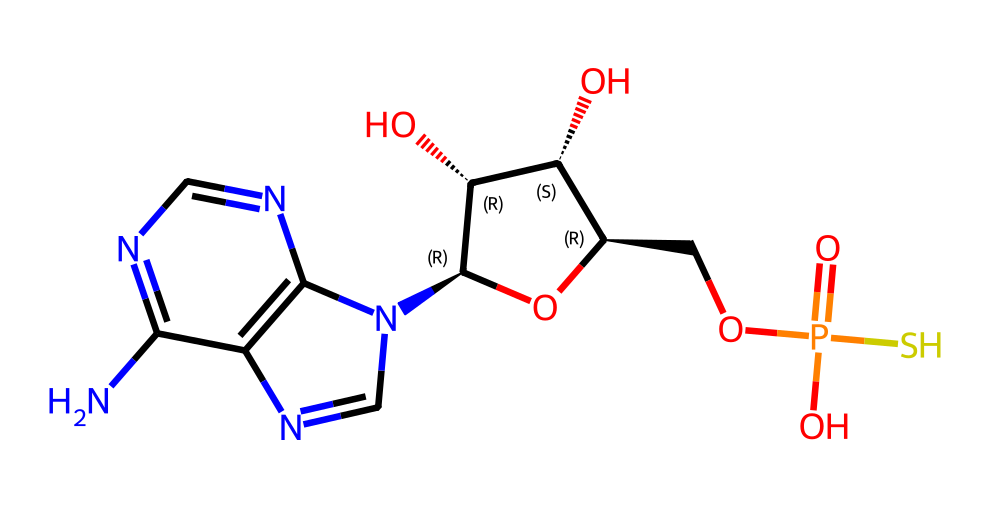What is the total number of atoms in this compound? To find the total number of atoms, we can count each unique atom type present in the SMILES representation. The atoms identified are Nitrogen (N), Carbon (C), Oxygen (O), and Sulfur (S). Counting each from the structure leads to a total of 22 atoms.
Answer: 22 How many sulfur atoms are present in this molecule? The structural representation shows only one sulfur atom (S) that is explicitly indicated in the SMILES string, confirming the presence of a thioether group typically seen in thiolated compounds.
Answer: 1 What type of functional group does the sulfur in this compound represent? In this SMILES format, the sulfur atom is part of a phosphate group that is linked to the DNA backbone, indicating a thioester linkage, typical for thiolated species in biochemical contexts.
Answer: thioether Is this compound likely to be water-soluble? Given the presence of hydroxyl (OH) groups and the phosphate moiety in the structure, the molecule is expected to be hydrophilic and thus likely to be water-soluble.
Answer: yes How many nitrogen atoms are in this compound? By examining the SMILES representation, we can identify there are five nitrogen atoms in the structure, commonly involved in forming rings and maintaining overall structural stability in nucleotide analogs.
Answer: 5 What is the significance of the thiol modification in genomic applications? The presence of a thiol group (–SH) in nucleic acids enhances stability and can facilitate interactions with metal ions, which is particularly useful for biosensing applications and can improve hybridization characteristics.
Answer: stability enhancement 